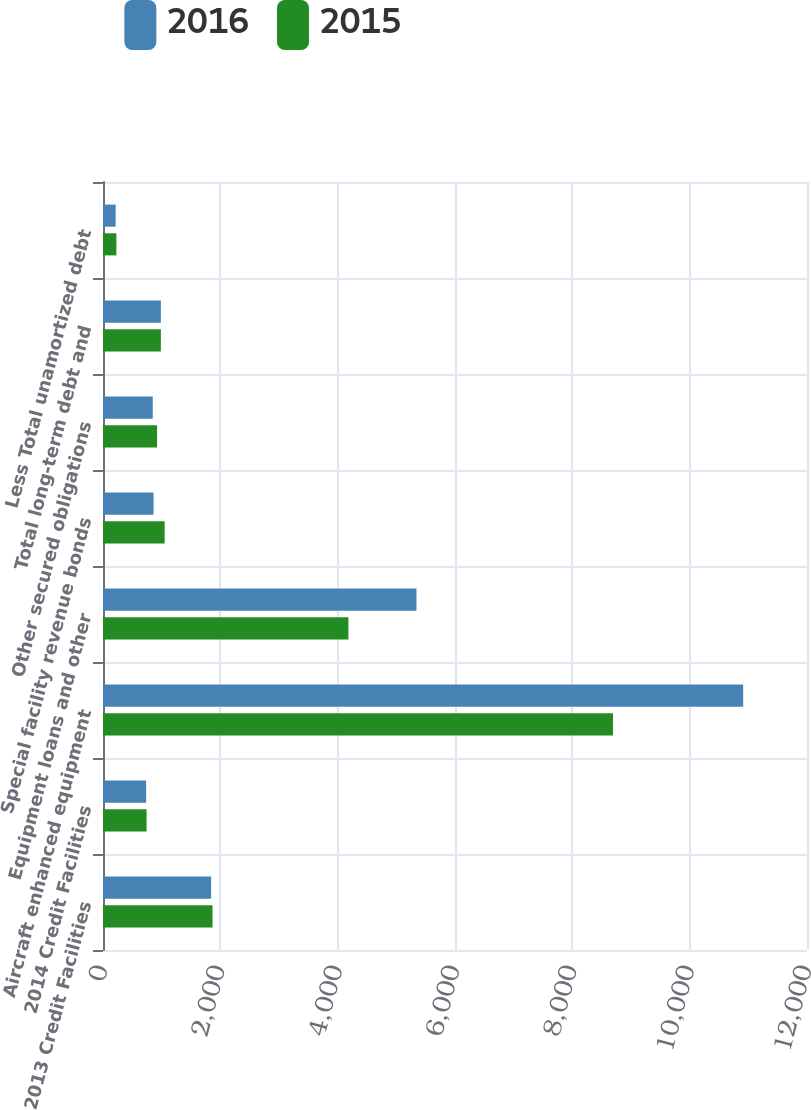Convert chart to OTSL. <chart><loc_0><loc_0><loc_500><loc_500><stacked_bar_chart><ecel><fcel>2013 Credit Facilities<fcel>2014 Credit Facilities<fcel>Aircraft enhanced equipment<fcel>Equipment loans and other<fcel>Special facility revenue bonds<fcel>Other secured obligations<fcel>Total long-term debt and<fcel>Less Total unamortized debt<nl><fcel>2016<fcel>1843<fcel>735<fcel>10912<fcel>5343<fcel>862<fcel>848<fcel>986.5<fcel>216<nl><fcel>2015<fcel>1867<fcel>743<fcel>8693<fcel>4183<fcel>1051<fcel>922<fcel>986.5<fcel>228<nl></chart> 